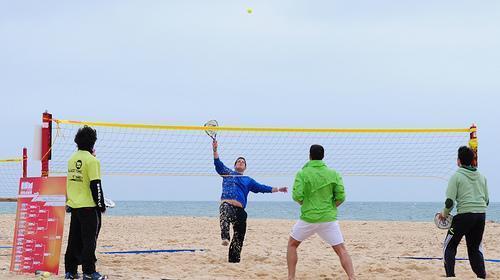How many nets are visible?
Give a very brief answer. 2. 